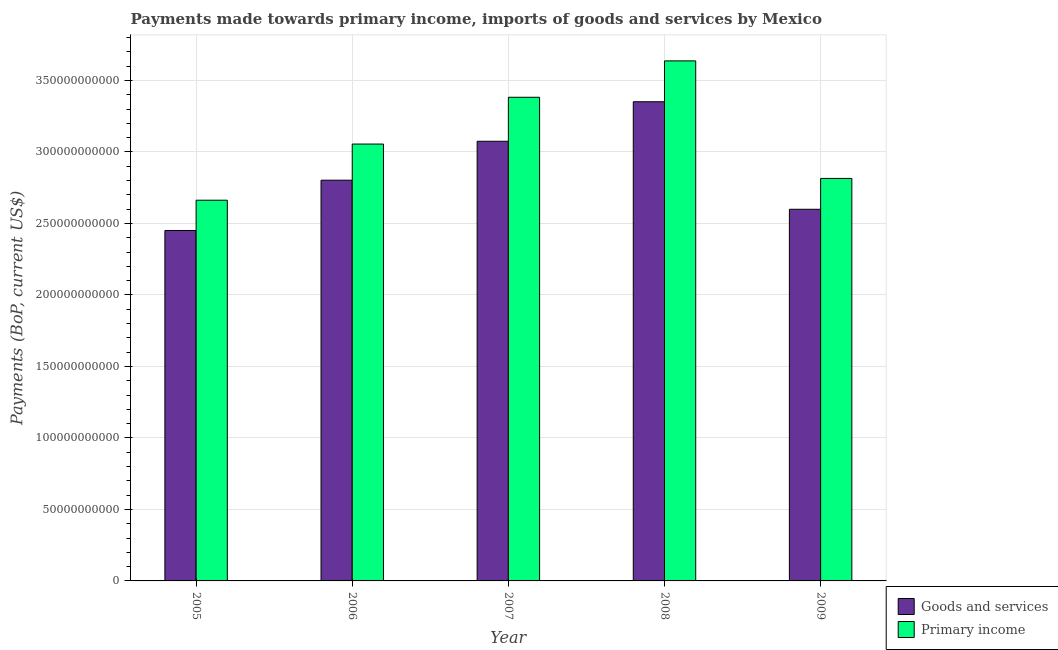How many different coloured bars are there?
Make the answer very short. 2. What is the label of the 4th group of bars from the left?
Ensure brevity in your answer.  2008. In how many cases, is the number of bars for a given year not equal to the number of legend labels?
Keep it short and to the point. 0. What is the payments made towards goods and services in 2008?
Your answer should be very brief. 3.35e+11. Across all years, what is the maximum payments made towards goods and services?
Give a very brief answer. 3.35e+11. Across all years, what is the minimum payments made towards primary income?
Give a very brief answer. 2.66e+11. In which year was the payments made towards primary income maximum?
Make the answer very short. 2008. What is the total payments made towards goods and services in the graph?
Your answer should be compact. 1.43e+12. What is the difference between the payments made towards primary income in 2007 and that in 2009?
Your answer should be very brief. 5.68e+1. What is the difference between the payments made towards primary income in 2006 and the payments made towards goods and services in 2007?
Give a very brief answer. -3.27e+1. What is the average payments made towards goods and services per year?
Your answer should be very brief. 2.86e+11. In the year 2008, what is the difference between the payments made towards goods and services and payments made towards primary income?
Offer a terse response. 0. What is the ratio of the payments made towards primary income in 2005 to that in 2007?
Keep it short and to the point. 0.79. Is the payments made towards primary income in 2006 less than that in 2007?
Provide a short and direct response. Yes. Is the difference between the payments made towards goods and services in 2006 and 2008 greater than the difference between the payments made towards primary income in 2006 and 2008?
Your answer should be very brief. No. What is the difference between the highest and the second highest payments made towards primary income?
Offer a very short reply. 2.55e+1. What is the difference between the highest and the lowest payments made towards primary income?
Give a very brief answer. 9.74e+1. What does the 1st bar from the left in 2005 represents?
Provide a short and direct response. Goods and services. What does the 1st bar from the right in 2007 represents?
Make the answer very short. Primary income. How many bars are there?
Your answer should be very brief. 10. How many years are there in the graph?
Your answer should be compact. 5. Are the values on the major ticks of Y-axis written in scientific E-notation?
Keep it short and to the point. No. Does the graph contain any zero values?
Offer a very short reply. No. Does the graph contain grids?
Ensure brevity in your answer.  Yes. How many legend labels are there?
Your response must be concise. 2. How are the legend labels stacked?
Provide a short and direct response. Vertical. What is the title of the graph?
Provide a succinct answer. Payments made towards primary income, imports of goods and services by Mexico. What is the label or title of the X-axis?
Provide a short and direct response. Year. What is the label or title of the Y-axis?
Your answer should be very brief. Payments (BoP, current US$). What is the Payments (BoP, current US$) in Goods and services in 2005?
Offer a terse response. 2.45e+11. What is the Payments (BoP, current US$) of Primary income in 2005?
Ensure brevity in your answer.  2.66e+11. What is the Payments (BoP, current US$) in Goods and services in 2006?
Your answer should be very brief. 2.80e+11. What is the Payments (BoP, current US$) of Primary income in 2006?
Your answer should be very brief. 3.06e+11. What is the Payments (BoP, current US$) in Goods and services in 2007?
Your answer should be compact. 3.08e+11. What is the Payments (BoP, current US$) in Primary income in 2007?
Your answer should be compact. 3.38e+11. What is the Payments (BoP, current US$) of Goods and services in 2008?
Offer a terse response. 3.35e+11. What is the Payments (BoP, current US$) in Primary income in 2008?
Ensure brevity in your answer.  3.64e+11. What is the Payments (BoP, current US$) in Goods and services in 2009?
Give a very brief answer. 2.60e+11. What is the Payments (BoP, current US$) of Primary income in 2009?
Your answer should be very brief. 2.82e+11. Across all years, what is the maximum Payments (BoP, current US$) of Goods and services?
Your answer should be very brief. 3.35e+11. Across all years, what is the maximum Payments (BoP, current US$) in Primary income?
Your response must be concise. 3.64e+11. Across all years, what is the minimum Payments (BoP, current US$) in Goods and services?
Ensure brevity in your answer.  2.45e+11. Across all years, what is the minimum Payments (BoP, current US$) of Primary income?
Your response must be concise. 2.66e+11. What is the total Payments (BoP, current US$) of Goods and services in the graph?
Provide a succinct answer. 1.43e+12. What is the total Payments (BoP, current US$) of Primary income in the graph?
Your response must be concise. 1.56e+12. What is the difference between the Payments (BoP, current US$) of Goods and services in 2005 and that in 2006?
Make the answer very short. -3.52e+1. What is the difference between the Payments (BoP, current US$) of Primary income in 2005 and that in 2006?
Make the answer very short. -3.93e+1. What is the difference between the Payments (BoP, current US$) of Goods and services in 2005 and that in 2007?
Give a very brief answer. -6.24e+1. What is the difference between the Payments (BoP, current US$) of Primary income in 2005 and that in 2007?
Your answer should be compact. -7.20e+1. What is the difference between the Payments (BoP, current US$) of Goods and services in 2005 and that in 2008?
Ensure brevity in your answer.  -9.00e+1. What is the difference between the Payments (BoP, current US$) in Primary income in 2005 and that in 2008?
Offer a very short reply. -9.74e+1. What is the difference between the Payments (BoP, current US$) in Goods and services in 2005 and that in 2009?
Your answer should be compact. -1.48e+1. What is the difference between the Payments (BoP, current US$) in Primary income in 2005 and that in 2009?
Ensure brevity in your answer.  -1.52e+1. What is the difference between the Payments (BoP, current US$) of Goods and services in 2006 and that in 2007?
Provide a short and direct response. -2.72e+1. What is the difference between the Payments (BoP, current US$) in Primary income in 2006 and that in 2007?
Offer a very short reply. -3.27e+1. What is the difference between the Payments (BoP, current US$) in Goods and services in 2006 and that in 2008?
Give a very brief answer. -5.49e+1. What is the difference between the Payments (BoP, current US$) in Primary income in 2006 and that in 2008?
Ensure brevity in your answer.  -5.82e+1. What is the difference between the Payments (BoP, current US$) in Goods and services in 2006 and that in 2009?
Provide a succinct answer. 2.03e+1. What is the difference between the Payments (BoP, current US$) of Primary income in 2006 and that in 2009?
Your answer should be compact. 2.40e+1. What is the difference between the Payments (BoP, current US$) of Goods and services in 2007 and that in 2008?
Give a very brief answer. -2.76e+1. What is the difference between the Payments (BoP, current US$) of Primary income in 2007 and that in 2008?
Make the answer very short. -2.55e+1. What is the difference between the Payments (BoP, current US$) in Goods and services in 2007 and that in 2009?
Your answer should be compact. 4.76e+1. What is the difference between the Payments (BoP, current US$) in Primary income in 2007 and that in 2009?
Offer a very short reply. 5.68e+1. What is the difference between the Payments (BoP, current US$) in Goods and services in 2008 and that in 2009?
Provide a succinct answer. 7.52e+1. What is the difference between the Payments (BoP, current US$) in Primary income in 2008 and that in 2009?
Your response must be concise. 8.22e+1. What is the difference between the Payments (BoP, current US$) of Goods and services in 2005 and the Payments (BoP, current US$) of Primary income in 2006?
Make the answer very short. -6.05e+1. What is the difference between the Payments (BoP, current US$) of Goods and services in 2005 and the Payments (BoP, current US$) of Primary income in 2007?
Your answer should be very brief. -9.32e+1. What is the difference between the Payments (BoP, current US$) in Goods and services in 2005 and the Payments (BoP, current US$) in Primary income in 2008?
Offer a terse response. -1.19e+11. What is the difference between the Payments (BoP, current US$) of Goods and services in 2005 and the Payments (BoP, current US$) of Primary income in 2009?
Offer a terse response. -3.64e+1. What is the difference between the Payments (BoP, current US$) in Goods and services in 2006 and the Payments (BoP, current US$) in Primary income in 2007?
Offer a terse response. -5.80e+1. What is the difference between the Payments (BoP, current US$) of Goods and services in 2006 and the Payments (BoP, current US$) of Primary income in 2008?
Your answer should be compact. -8.35e+1. What is the difference between the Payments (BoP, current US$) in Goods and services in 2006 and the Payments (BoP, current US$) in Primary income in 2009?
Provide a short and direct response. -1.24e+09. What is the difference between the Payments (BoP, current US$) of Goods and services in 2007 and the Payments (BoP, current US$) of Primary income in 2008?
Your response must be concise. -5.62e+1. What is the difference between the Payments (BoP, current US$) of Goods and services in 2007 and the Payments (BoP, current US$) of Primary income in 2009?
Make the answer very short. 2.60e+1. What is the difference between the Payments (BoP, current US$) of Goods and services in 2008 and the Payments (BoP, current US$) of Primary income in 2009?
Your answer should be compact. 5.36e+1. What is the average Payments (BoP, current US$) in Goods and services per year?
Provide a short and direct response. 2.86e+11. What is the average Payments (BoP, current US$) of Primary income per year?
Your answer should be compact. 3.11e+11. In the year 2005, what is the difference between the Payments (BoP, current US$) in Goods and services and Payments (BoP, current US$) in Primary income?
Keep it short and to the point. -2.12e+1. In the year 2006, what is the difference between the Payments (BoP, current US$) of Goods and services and Payments (BoP, current US$) of Primary income?
Offer a terse response. -2.53e+1. In the year 2007, what is the difference between the Payments (BoP, current US$) of Goods and services and Payments (BoP, current US$) of Primary income?
Offer a terse response. -3.08e+1. In the year 2008, what is the difference between the Payments (BoP, current US$) in Goods and services and Payments (BoP, current US$) in Primary income?
Offer a terse response. -2.86e+1. In the year 2009, what is the difference between the Payments (BoP, current US$) of Goods and services and Payments (BoP, current US$) of Primary income?
Your answer should be compact. -2.16e+1. What is the ratio of the Payments (BoP, current US$) in Goods and services in 2005 to that in 2006?
Make the answer very short. 0.87. What is the ratio of the Payments (BoP, current US$) of Primary income in 2005 to that in 2006?
Your answer should be very brief. 0.87. What is the ratio of the Payments (BoP, current US$) in Goods and services in 2005 to that in 2007?
Give a very brief answer. 0.8. What is the ratio of the Payments (BoP, current US$) in Primary income in 2005 to that in 2007?
Provide a short and direct response. 0.79. What is the ratio of the Payments (BoP, current US$) of Goods and services in 2005 to that in 2008?
Provide a short and direct response. 0.73. What is the ratio of the Payments (BoP, current US$) of Primary income in 2005 to that in 2008?
Your answer should be very brief. 0.73. What is the ratio of the Payments (BoP, current US$) of Goods and services in 2005 to that in 2009?
Provide a succinct answer. 0.94. What is the ratio of the Payments (BoP, current US$) of Primary income in 2005 to that in 2009?
Provide a short and direct response. 0.95. What is the ratio of the Payments (BoP, current US$) in Goods and services in 2006 to that in 2007?
Offer a terse response. 0.91. What is the ratio of the Payments (BoP, current US$) in Primary income in 2006 to that in 2007?
Offer a very short reply. 0.9. What is the ratio of the Payments (BoP, current US$) of Goods and services in 2006 to that in 2008?
Keep it short and to the point. 0.84. What is the ratio of the Payments (BoP, current US$) of Primary income in 2006 to that in 2008?
Ensure brevity in your answer.  0.84. What is the ratio of the Payments (BoP, current US$) in Goods and services in 2006 to that in 2009?
Your answer should be very brief. 1.08. What is the ratio of the Payments (BoP, current US$) of Primary income in 2006 to that in 2009?
Keep it short and to the point. 1.09. What is the ratio of the Payments (BoP, current US$) in Goods and services in 2007 to that in 2008?
Your answer should be very brief. 0.92. What is the ratio of the Payments (BoP, current US$) in Primary income in 2007 to that in 2008?
Keep it short and to the point. 0.93. What is the ratio of the Payments (BoP, current US$) of Goods and services in 2007 to that in 2009?
Your response must be concise. 1.18. What is the ratio of the Payments (BoP, current US$) of Primary income in 2007 to that in 2009?
Offer a terse response. 1.2. What is the ratio of the Payments (BoP, current US$) of Goods and services in 2008 to that in 2009?
Offer a very short reply. 1.29. What is the ratio of the Payments (BoP, current US$) in Primary income in 2008 to that in 2009?
Offer a very short reply. 1.29. What is the difference between the highest and the second highest Payments (BoP, current US$) of Goods and services?
Provide a short and direct response. 2.76e+1. What is the difference between the highest and the second highest Payments (BoP, current US$) in Primary income?
Make the answer very short. 2.55e+1. What is the difference between the highest and the lowest Payments (BoP, current US$) in Goods and services?
Provide a short and direct response. 9.00e+1. What is the difference between the highest and the lowest Payments (BoP, current US$) of Primary income?
Your response must be concise. 9.74e+1. 